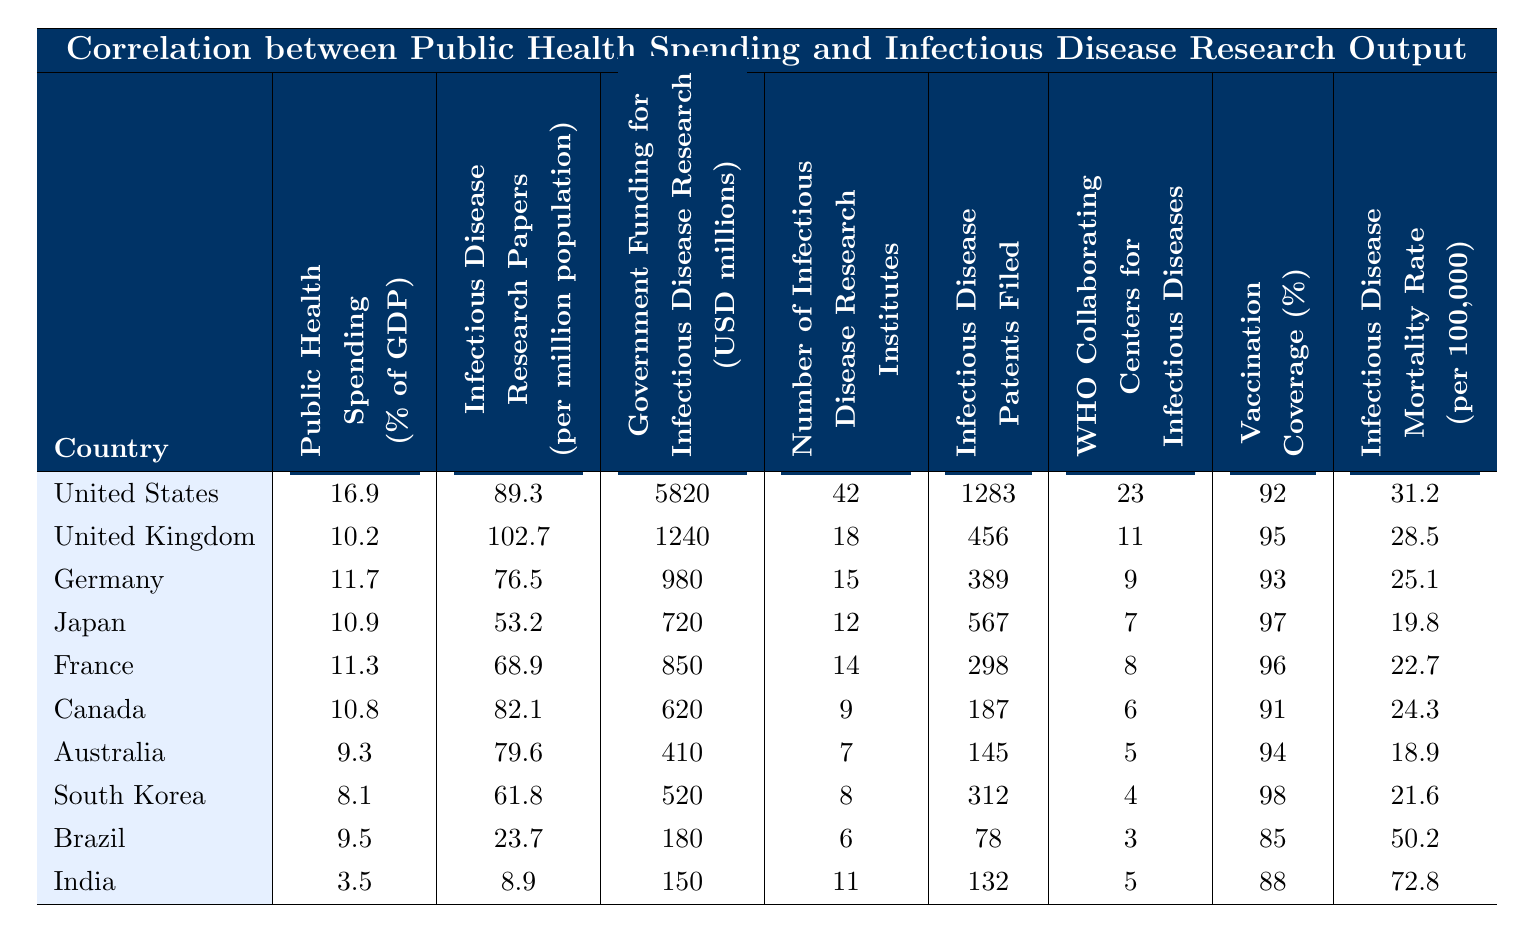What country has the highest public health spending as a percentage of GDP? By examining the "Public Health Spending (% of GDP)" column, the United States shows the highest value at 16.9%.
Answer: United States Which country produced the most infectious disease research papers per million population? Looking at the "Infectious Disease Research Papers (per million population)" column, the United Kingdom has the highest at 102.7 papers.
Answer: United Kingdom What is the total government funding for infectious disease research by the top three countries? Summing up the government funding for the United States (5820), United Kingdom (1240), and Germany (980) gives 5820 + 1240 + 980 = 8040 million USD.
Answer: 8040 million USD Which country has the lowest vaccination coverage percentage? By checking the "Vaccination Coverage (%)" column, India has the lowest coverage at 88%.
Answer: India Is it true that Brazil has a lower infectious disease research output compared to India? Comparing the "Infectious Disease Research Papers (per million population)", Brazil with 23.7 papers is indeed lower than India's 8.9, making the statement true.
Answer: True How many infectious disease research institutes are there in Canada and Australia combined? Adding the number of institutes in Canada (9) and Australia (7) results in 9 + 7 = 16 institutes.
Answer: 16 institutes What is the ratio of infectious disease patents filed in the United States to those filed in India? The United States filed 1283 patents and India filed 132. The ratio is 1283 / 132 ≈ 9.7.
Answer: Approximately 9.7 Which country has the highest infectious disease mortality rate and what is that rate? In the "Infectious Disease Mortality Rate (per 100,000)" column, India has the highest rate at 72.8 per 100,000.
Answer: India, 72.8 per 100,000 Calculate the average public health spending among the countries listed in the table. Summing the public health spending percentages: 16.9 + 10.2 + 11.7 + 10.9 + 11.3 + 10.8 + 9.3 + 8.1 + 9.5 + 3.5 =  92.2. Dividing by 10 countries gives an average of 9.22%.
Answer: 9.22% Which country has more WHO Collaborating Centers for Infectious Diseases, Germany or France? By comparing the "WHO Collaborating Centers for Infectious Diseases", Germany has 9 centers while France has 8. Therefore, Germany has more.
Answer: Germany 